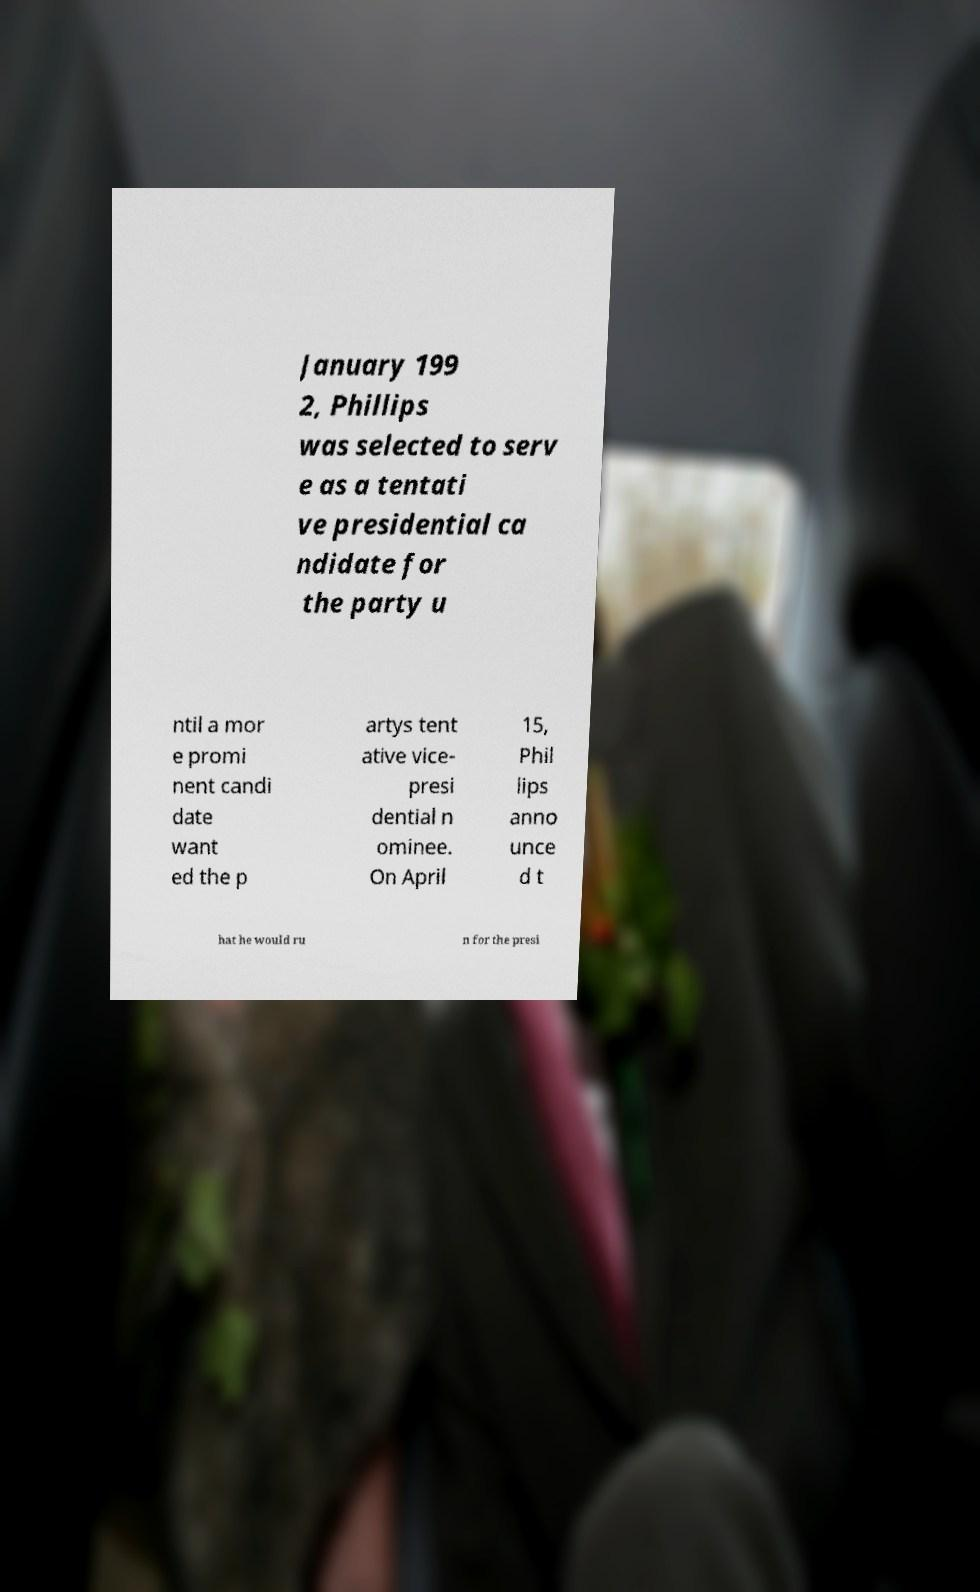Please read and relay the text visible in this image. What does it say? January 199 2, Phillips was selected to serv e as a tentati ve presidential ca ndidate for the party u ntil a mor e promi nent candi date want ed the p artys tent ative vice- presi dential n ominee. On April 15, Phil lips anno unce d t hat he would ru n for the presi 